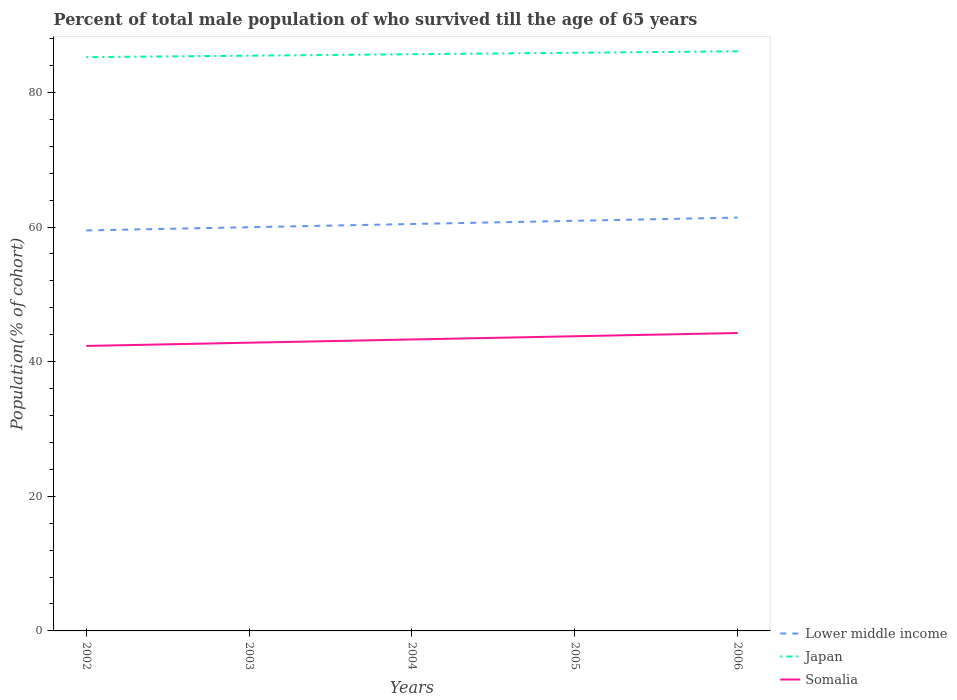How many different coloured lines are there?
Ensure brevity in your answer.  3. Does the line corresponding to Lower middle income intersect with the line corresponding to Japan?
Make the answer very short. No. Across all years, what is the maximum percentage of total male population who survived till the age of 65 years in Japan?
Your answer should be very brief. 85.23. In which year was the percentage of total male population who survived till the age of 65 years in Somalia maximum?
Provide a short and direct response. 2002. What is the total percentage of total male population who survived till the age of 65 years in Japan in the graph?
Your answer should be compact. -0.87. What is the difference between the highest and the second highest percentage of total male population who survived till the age of 65 years in Japan?
Offer a very short reply. 0.87. What is the difference between two consecutive major ticks on the Y-axis?
Make the answer very short. 20. Are the values on the major ticks of Y-axis written in scientific E-notation?
Ensure brevity in your answer.  No. What is the title of the graph?
Ensure brevity in your answer.  Percent of total male population of who survived till the age of 65 years. Does "Pacific island small states" appear as one of the legend labels in the graph?
Keep it short and to the point. No. What is the label or title of the X-axis?
Offer a terse response. Years. What is the label or title of the Y-axis?
Offer a terse response. Population(% of cohort). What is the Population(% of cohort) of Lower middle income in 2002?
Your answer should be very brief. 59.49. What is the Population(% of cohort) of Japan in 2002?
Your answer should be compact. 85.23. What is the Population(% of cohort) of Somalia in 2002?
Ensure brevity in your answer.  42.33. What is the Population(% of cohort) in Lower middle income in 2003?
Provide a short and direct response. 59.97. What is the Population(% of cohort) in Japan in 2003?
Your answer should be very brief. 85.45. What is the Population(% of cohort) of Somalia in 2003?
Ensure brevity in your answer.  42.81. What is the Population(% of cohort) in Lower middle income in 2004?
Make the answer very short. 60.45. What is the Population(% of cohort) in Japan in 2004?
Ensure brevity in your answer.  85.67. What is the Population(% of cohort) of Somalia in 2004?
Your response must be concise. 43.29. What is the Population(% of cohort) of Lower middle income in 2005?
Provide a succinct answer. 60.92. What is the Population(% of cohort) of Japan in 2005?
Provide a succinct answer. 85.88. What is the Population(% of cohort) of Somalia in 2005?
Provide a succinct answer. 43.77. What is the Population(% of cohort) in Lower middle income in 2006?
Keep it short and to the point. 61.4. What is the Population(% of cohort) of Japan in 2006?
Keep it short and to the point. 86.1. What is the Population(% of cohort) in Somalia in 2006?
Provide a short and direct response. 44.25. Across all years, what is the maximum Population(% of cohort) in Lower middle income?
Provide a succinct answer. 61.4. Across all years, what is the maximum Population(% of cohort) in Japan?
Offer a terse response. 86.1. Across all years, what is the maximum Population(% of cohort) of Somalia?
Ensure brevity in your answer.  44.25. Across all years, what is the minimum Population(% of cohort) in Lower middle income?
Ensure brevity in your answer.  59.49. Across all years, what is the minimum Population(% of cohort) of Japan?
Make the answer very short. 85.23. Across all years, what is the minimum Population(% of cohort) of Somalia?
Offer a very short reply. 42.33. What is the total Population(% of cohort) in Lower middle income in the graph?
Give a very brief answer. 302.23. What is the total Population(% of cohort) in Japan in the graph?
Provide a succinct answer. 428.33. What is the total Population(% of cohort) of Somalia in the graph?
Your answer should be compact. 216.47. What is the difference between the Population(% of cohort) of Lower middle income in 2002 and that in 2003?
Ensure brevity in your answer.  -0.48. What is the difference between the Population(% of cohort) in Japan in 2002 and that in 2003?
Ensure brevity in your answer.  -0.22. What is the difference between the Population(% of cohort) of Somalia in 2002 and that in 2003?
Offer a very short reply. -0.48. What is the difference between the Population(% of cohort) of Lower middle income in 2002 and that in 2004?
Keep it short and to the point. -0.95. What is the difference between the Population(% of cohort) in Japan in 2002 and that in 2004?
Your answer should be compact. -0.43. What is the difference between the Population(% of cohort) in Somalia in 2002 and that in 2004?
Your response must be concise. -0.96. What is the difference between the Population(% of cohort) of Lower middle income in 2002 and that in 2005?
Make the answer very short. -1.43. What is the difference between the Population(% of cohort) of Japan in 2002 and that in 2005?
Offer a terse response. -0.65. What is the difference between the Population(% of cohort) in Somalia in 2002 and that in 2005?
Make the answer very short. -1.44. What is the difference between the Population(% of cohort) of Lower middle income in 2002 and that in 2006?
Ensure brevity in your answer.  -1.91. What is the difference between the Population(% of cohort) in Japan in 2002 and that in 2006?
Give a very brief answer. -0.87. What is the difference between the Population(% of cohort) of Somalia in 2002 and that in 2006?
Give a very brief answer. -1.92. What is the difference between the Population(% of cohort) in Lower middle income in 2003 and that in 2004?
Provide a succinct answer. -0.48. What is the difference between the Population(% of cohort) of Japan in 2003 and that in 2004?
Provide a short and direct response. -0.22. What is the difference between the Population(% of cohort) of Somalia in 2003 and that in 2004?
Ensure brevity in your answer.  -0.48. What is the difference between the Population(% of cohort) in Lower middle income in 2003 and that in 2005?
Your answer should be compact. -0.95. What is the difference between the Population(% of cohort) of Japan in 2003 and that in 2005?
Provide a succinct answer. -0.43. What is the difference between the Population(% of cohort) of Somalia in 2003 and that in 2005?
Your answer should be very brief. -0.96. What is the difference between the Population(% of cohort) in Lower middle income in 2003 and that in 2006?
Make the answer very short. -1.43. What is the difference between the Population(% of cohort) in Japan in 2003 and that in 2006?
Keep it short and to the point. -0.65. What is the difference between the Population(% of cohort) in Somalia in 2003 and that in 2006?
Your response must be concise. -1.44. What is the difference between the Population(% of cohort) in Lower middle income in 2004 and that in 2005?
Keep it short and to the point. -0.48. What is the difference between the Population(% of cohort) in Japan in 2004 and that in 2005?
Give a very brief answer. -0.22. What is the difference between the Population(% of cohort) in Somalia in 2004 and that in 2005?
Offer a terse response. -0.48. What is the difference between the Population(% of cohort) in Lower middle income in 2004 and that in 2006?
Ensure brevity in your answer.  -0.95. What is the difference between the Population(% of cohort) of Japan in 2004 and that in 2006?
Provide a short and direct response. -0.43. What is the difference between the Population(% of cohort) of Somalia in 2004 and that in 2006?
Provide a succinct answer. -0.96. What is the difference between the Population(% of cohort) in Lower middle income in 2005 and that in 2006?
Provide a short and direct response. -0.48. What is the difference between the Population(% of cohort) of Japan in 2005 and that in 2006?
Your response must be concise. -0.22. What is the difference between the Population(% of cohort) of Somalia in 2005 and that in 2006?
Give a very brief answer. -0.48. What is the difference between the Population(% of cohort) in Lower middle income in 2002 and the Population(% of cohort) in Japan in 2003?
Offer a very short reply. -25.96. What is the difference between the Population(% of cohort) of Lower middle income in 2002 and the Population(% of cohort) of Somalia in 2003?
Provide a short and direct response. 16.68. What is the difference between the Population(% of cohort) of Japan in 2002 and the Population(% of cohort) of Somalia in 2003?
Make the answer very short. 42.42. What is the difference between the Population(% of cohort) of Lower middle income in 2002 and the Population(% of cohort) of Japan in 2004?
Your response must be concise. -26.17. What is the difference between the Population(% of cohort) of Lower middle income in 2002 and the Population(% of cohort) of Somalia in 2004?
Provide a short and direct response. 16.2. What is the difference between the Population(% of cohort) in Japan in 2002 and the Population(% of cohort) in Somalia in 2004?
Give a very brief answer. 41.94. What is the difference between the Population(% of cohort) of Lower middle income in 2002 and the Population(% of cohort) of Japan in 2005?
Keep it short and to the point. -26.39. What is the difference between the Population(% of cohort) of Lower middle income in 2002 and the Population(% of cohort) of Somalia in 2005?
Your answer should be compact. 15.72. What is the difference between the Population(% of cohort) of Japan in 2002 and the Population(% of cohort) of Somalia in 2005?
Offer a terse response. 41.46. What is the difference between the Population(% of cohort) of Lower middle income in 2002 and the Population(% of cohort) of Japan in 2006?
Your answer should be very brief. -26.61. What is the difference between the Population(% of cohort) in Lower middle income in 2002 and the Population(% of cohort) in Somalia in 2006?
Ensure brevity in your answer.  15.24. What is the difference between the Population(% of cohort) of Japan in 2002 and the Population(% of cohort) of Somalia in 2006?
Offer a very short reply. 40.98. What is the difference between the Population(% of cohort) of Lower middle income in 2003 and the Population(% of cohort) of Japan in 2004?
Provide a succinct answer. -25.7. What is the difference between the Population(% of cohort) of Lower middle income in 2003 and the Population(% of cohort) of Somalia in 2004?
Provide a succinct answer. 16.68. What is the difference between the Population(% of cohort) in Japan in 2003 and the Population(% of cohort) in Somalia in 2004?
Your response must be concise. 42.16. What is the difference between the Population(% of cohort) in Lower middle income in 2003 and the Population(% of cohort) in Japan in 2005?
Your answer should be very brief. -25.91. What is the difference between the Population(% of cohort) of Lower middle income in 2003 and the Population(% of cohort) of Somalia in 2005?
Your response must be concise. 16.2. What is the difference between the Population(% of cohort) of Japan in 2003 and the Population(% of cohort) of Somalia in 2005?
Keep it short and to the point. 41.68. What is the difference between the Population(% of cohort) in Lower middle income in 2003 and the Population(% of cohort) in Japan in 2006?
Offer a very short reply. -26.13. What is the difference between the Population(% of cohort) in Lower middle income in 2003 and the Population(% of cohort) in Somalia in 2006?
Your response must be concise. 15.72. What is the difference between the Population(% of cohort) in Japan in 2003 and the Population(% of cohort) in Somalia in 2006?
Provide a succinct answer. 41.2. What is the difference between the Population(% of cohort) of Lower middle income in 2004 and the Population(% of cohort) of Japan in 2005?
Give a very brief answer. -25.44. What is the difference between the Population(% of cohort) of Lower middle income in 2004 and the Population(% of cohort) of Somalia in 2005?
Provide a short and direct response. 16.67. What is the difference between the Population(% of cohort) of Japan in 2004 and the Population(% of cohort) of Somalia in 2005?
Give a very brief answer. 41.89. What is the difference between the Population(% of cohort) of Lower middle income in 2004 and the Population(% of cohort) of Japan in 2006?
Give a very brief answer. -25.65. What is the difference between the Population(% of cohort) of Lower middle income in 2004 and the Population(% of cohort) of Somalia in 2006?
Provide a short and direct response. 16.19. What is the difference between the Population(% of cohort) in Japan in 2004 and the Population(% of cohort) in Somalia in 2006?
Your response must be concise. 41.41. What is the difference between the Population(% of cohort) of Lower middle income in 2005 and the Population(% of cohort) of Japan in 2006?
Offer a very short reply. -25.18. What is the difference between the Population(% of cohort) in Lower middle income in 2005 and the Population(% of cohort) in Somalia in 2006?
Give a very brief answer. 16.67. What is the difference between the Population(% of cohort) of Japan in 2005 and the Population(% of cohort) of Somalia in 2006?
Provide a succinct answer. 41.63. What is the average Population(% of cohort) of Lower middle income per year?
Provide a succinct answer. 60.45. What is the average Population(% of cohort) in Japan per year?
Ensure brevity in your answer.  85.67. What is the average Population(% of cohort) of Somalia per year?
Offer a very short reply. 43.29. In the year 2002, what is the difference between the Population(% of cohort) of Lower middle income and Population(% of cohort) of Japan?
Your response must be concise. -25.74. In the year 2002, what is the difference between the Population(% of cohort) in Lower middle income and Population(% of cohort) in Somalia?
Keep it short and to the point. 17.16. In the year 2002, what is the difference between the Population(% of cohort) of Japan and Population(% of cohort) of Somalia?
Offer a terse response. 42.9. In the year 2003, what is the difference between the Population(% of cohort) of Lower middle income and Population(% of cohort) of Japan?
Provide a succinct answer. -25.48. In the year 2003, what is the difference between the Population(% of cohort) of Lower middle income and Population(% of cohort) of Somalia?
Provide a succinct answer. 17.16. In the year 2003, what is the difference between the Population(% of cohort) in Japan and Population(% of cohort) in Somalia?
Make the answer very short. 42.64. In the year 2004, what is the difference between the Population(% of cohort) of Lower middle income and Population(% of cohort) of Japan?
Make the answer very short. -25.22. In the year 2004, what is the difference between the Population(% of cohort) in Lower middle income and Population(% of cohort) in Somalia?
Keep it short and to the point. 17.15. In the year 2004, what is the difference between the Population(% of cohort) in Japan and Population(% of cohort) in Somalia?
Give a very brief answer. 42.37. In the year 2005, what is the difference between the Population(% of cohort) of Lower middle income and Population(% of cohort) of Japan?
Your answer should be compact. -24.96. In the year 2005, what is the difference between the Population(% of cohort) in Lower middle income and Population(% of cohort) in Somalia?
Provide a short and direct response. 17.15. In the year 2005, what is the difference between the Population(% of cohort) of Japan and Population(% of cohort) of Somalia?
Give a very brief answer. 42.11. In the year 2006, what is the difference between the Population(% of cohort) of Lower middle income and Population(% of cohort) of Japan?
Provide a short and direct response. -24.7. In the year 2006, what is the difference between the Population(% of cohort) in Lower middle income and Population(% of cohort) in Somalia?
Offer a terse response. 17.15. In the year 2006, what is the difference between the Population(% of cohort) in Japan and Population(% of cohort) in Somalia?
Your response must be concise. 41.85. What is the ratio of the Population(% of cohort) of Japan in 2002 to that in 2003?
Ensure brevity in your answer.  1. What is the ratio of the Population(% of cohort) in Lower middle income in 2002 to that in 2004?
Offer a terse response. 0.98. What is the ratio of the Population(% of cohort) of Japan in 2002 to that in 2004?
Provide a short and direct response. 0.99. What is the ratio of the Population(% of cohort) in Somalia in 2002 to that in 2004?
Provide a short and direct response. 0.98. What is the ratio of the Population(% of cohort) of Lower middle income in 2002 to that in 2005?
Make the answer very short. 0.98. What is the ratio of the Population(% of cohort) of Somalia in 2002 to that in 2005?
Keep it short and to the point. 0.97. What is the ratio of the Population(% of cohort) in Lower middle income in 2002 to that in 2006?
Your response must be concise. 0.97. What is the ratio of the Population(% of cohort) in Somalia in 2002 to that in 2006?
Your answer should be compact. 0.96. What is the ratio of the Population(% of cohort) in Somalia in 2003 to that in 2004?
Ensure brevity in your answer.  0.99. What is the ratio of the Population(% of cohort) of Lower middle income in 2003 to that in 2005?
Make the answer very short. 0.98. What is the ratio of the Population(% of cohort) of Somalia in 2003 to that in 2005?
Your answer should be very brief. 0.98. What is the ratio of the Population(% of cohort) of Lower middle income in 2003 to that in 2006?
Offer a terse response. 0.98. What is the ratio of the Population(% of cohort) of Somalia in 2003 to that in 2006?
Your answer should be very brief. 0.97. What is the ratio of the Population(% of cohort) in Lower middle income in 2004 to that in 2006?
Your answer should be compact. 0.98. What is the ratio of the Population(% of cohort) of Japan in 2004 to that in 2006?
Make the answer very short. 0.99. What is the ratio of the Population(% of cohort) of Somalia in 2004 to that in 2006?
Provide a short and direct response. 0.98. What is the ratio of the Population(% of cohort) in Lower middle income in 2005 to that in 2006?
Offer a very short reply. 0.99. What is the ratio of the Population(% of cohort) of Somalia in 2005 to that in 2006?
Your answer should be compact. 0.99. What is the difference between the highest and the second highest Population(% of cohort) in Lower middle income?
Ensure brevity in your answer.  0.48. What is the difference between the highest and the second highest Population(% of cohort) in Japan?
Your answer should be compact. 0.22. What is the difference between the highest and the second highest Population(% of cohort) of Somalia?
Your answer should be very brief. 0.48. What is the difference between the highest and the lowest Population(% of cohort) in Lower middle income?
Keep it short and to the point. 1.91. What is the difference between the highest and the lowest Population(% of cohort) in Japan?
Your answer should be very brief. 0.87. What is the difference between the highest and the lowest Population(% of cohort) in Somalia?
Offer a very short reply. 1.92. 